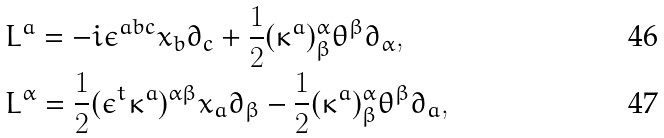Convert formula to latex. <formula><loc_0><loc_0><loc_500><loc_500>& L ^ { a } = - i \epsilon ^ { a b c } x _ { b } \partial _ { c } + \frac { 1 } { 2 } ( \kappa ^ { a } ) _ { \beta } ^ { \alpha } \theta ^ { \beta } \partial _ { \alpha } , \\ & L ^ { \alpha } = \frac { 1 } { 2 } ( \epsilon ^ { t } \kappa ^ { a } ) ^ { \alpha \beta } x _ { a } \partial _ { \beta } - \frac { 1 } { 2 } ( \kappa ^ { a } ) _ { \beta } ^ { \alpha } \theta ^ { \beta } \partial _ { a } ,</formula> 